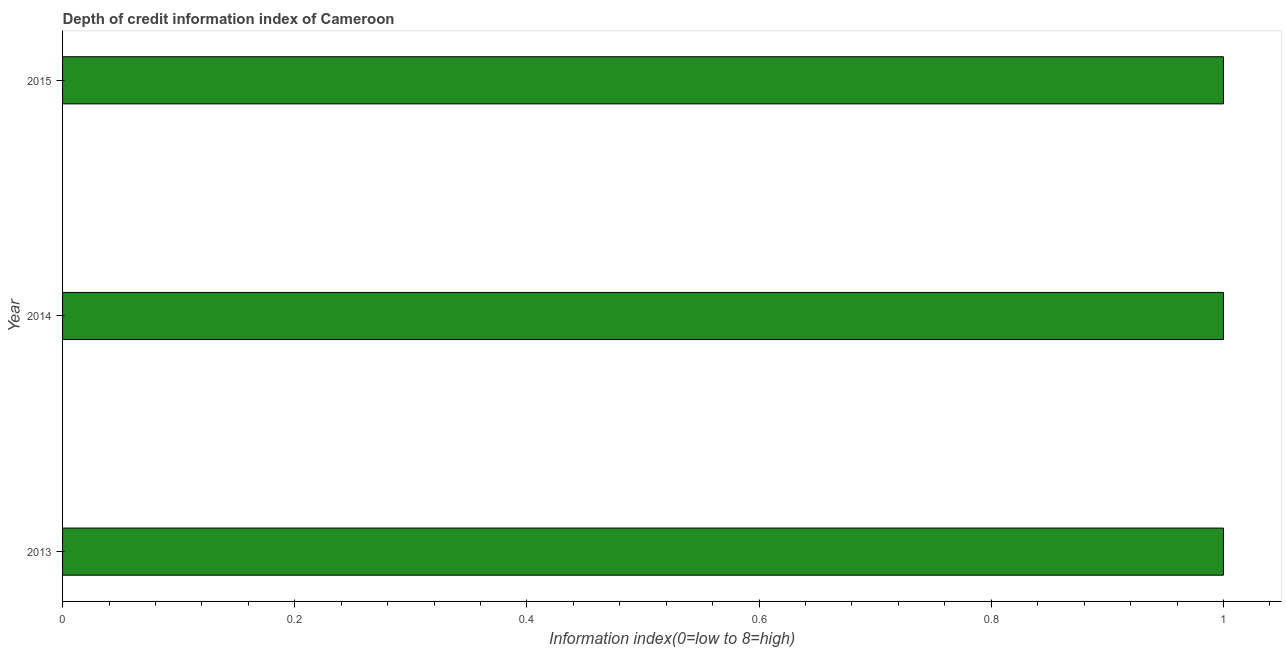What is the title of the graph?
Your answer should be compact. Depth of credit information index of Cameroon. What is the label or title of the X-axis?
Give a very brief answer. Information index(0=low to 8=high). What is the label or title of the Y-axis?
Your answer should be compact. Year. Across all years, what is the minimum depth of credit information index?
Your response must be concise. 1. In which year was the depth of credit information index minimum?
Your response must be concise. 2013. What is the median depth of credit information index?
Your answer should be compact. 1. Do a majority of the years between 2014 and 2013 (inclusive) have depth of credit information index greater than 0.72 ?
Ensure brevity in your answer.  No. What is the ratio of the depth of credit information index in 2014 to that in 2015?
Offer a terse response. 1. Is the depth of credit information index in 2013 less than that in 2015?
Make the answer very short. No. Is the difference between the depth of credit information index in 2014 and 2015 greater than the difference between any two years?
Keep it short and to the point. Yes. What is the difference between the highest and the lowest depth of credit information index?
Ensure brevity in your answer.  0. Are all the bars in the graph horizontal?
Offer a terse response. Yes. How many years are there in the graph?
Your response must be concise. 3. What is the Information index(0=low to 8=high) in 2013?
Offer a terse response. 1. What is the Information index(0=low to 8=high) in 2015?
Provide a succinct answer. 1. What is the difference between the Information index(0=low to 8=high) in 2013 and 2015?
Keep it short and to the point. 0. 